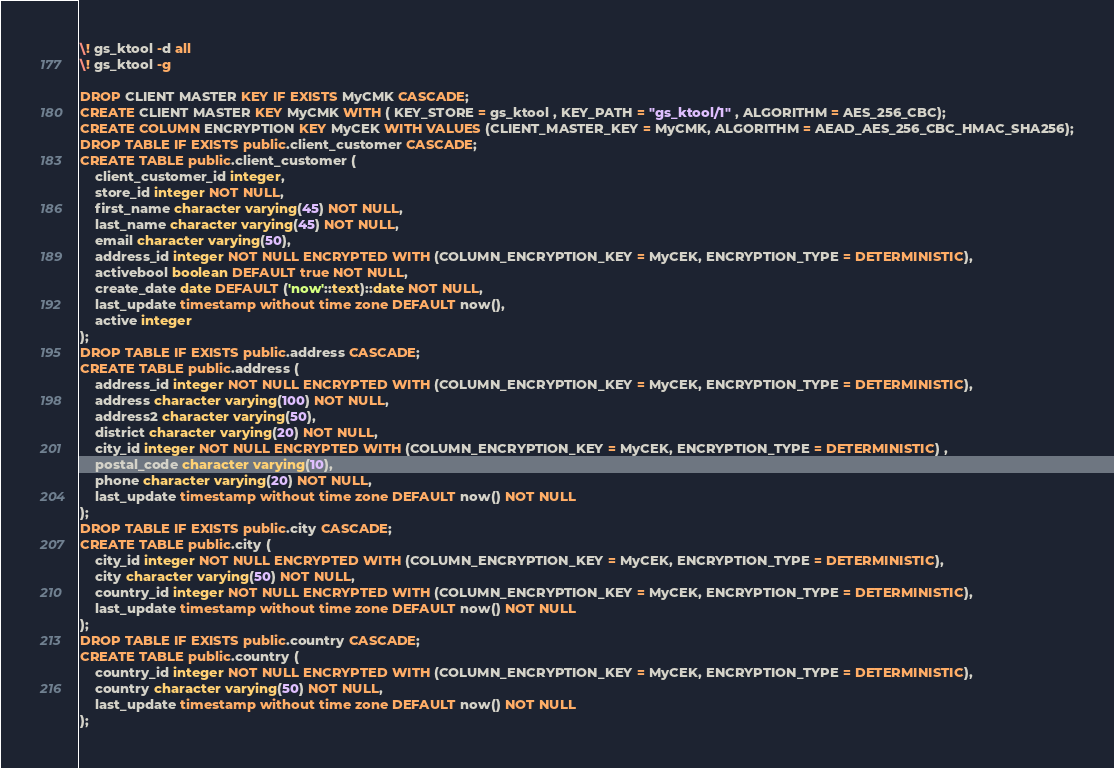<code> <loc_0><loc_0><loc_500><loc_500><_SQL_>\! gs_ktool -d all
\! gs_ktool -g

DROP CLIENT MASTER KEY IF EXISTS MyCMK CASCADE;
CREATE CLIENT MASTER KEY MyCMK WITH ( KEY_STORE = gs_ktool , KEY_PATH = "gs_ktool/1" , ALGORITHM = AES_256_CBC);
CREATE COLUMN ENCRYPTION KEY MyCEK WITH VALUES (CLIENT_MASTER_KEY = MyCMK, ALGORITHM = AEAD_AES_256_CBC_HMAC_SHA256);
DROP TABLE IF EXISTS public.client_customer CASCADE;
CREATE TABLE public.client_customer (
    client_customer_id integer, 
    store_id integer NOT NULL,
    first_name character varying(45) NOT NULL,
    last_name character varying(45) NOT NULL,
    email character varying(50),
    address_id integer NOT NULL ENCRYPTED WITH (COLUMN_ENCRYPTION_KEY = MyCEK, ENCRYPTION_TYPE = DETERMINISTIC),
    activebool boolean DEFAULT true NOT NULL,
    create_date date DEFAULT ('now'::text)::date NOT NULL,
    last_update timestamp without time zone DEFAULT now(),
    active integer
);
DROP TABLE IF EXISTS public.address CASCADE;
CREATE TABLE public.address (
    address_id integer NOT NULL ENCRYPTED WITH (COLUMN_ENCRYPTION_KEY = MyCEK, ENCRYPTION_TYPE = DETERMINISTIC),
    address character varying(100) NOT NULL,
    address2 character varying(50),
    district character varying(20) NOT NULL,
    city_id integer NOT NULL ENCRYPTED WITH (COLUMN_ENCRYPTION_KEY = MyCEK, ENCRYPTION_TYPE = DETERMINISTIC) ,
    postal_code character varying(10),
    phone character varying(20) NOT NULL,
    last_update timestamp without time zone DEFAULT now() NOT NULL
);
DROP TABLE IF EXISTS public.city CASCADE;
CREATE TABLE public.city (
    city_id integer NOT NULL ENCRYPTED WITH (COLUMN_ENCRYPTION_KEY = MyCEK, ENCRYPTION_TYPE = DETERMINISTIC),
    city character varying(50) NOT NULL,
    country_id integer NOT NULL ENCRYPTED WITH (COLUMN_ENCRYPTION_KEY = MyCEK, ENCRYPTION_TYPE = DETERMINISTIC),
    last_update timestamp without time zone DEFAULT now() NOT NULL
);
DROP TABLE IF EXISTS public.country CASCADE;
CREATE TABLE public.country (
    country_id integer NOT NULL ENCRYPTED WITH (COLUMN_ENCRYPTION_KEY = MyCEK, ENCRYPTION_TYPE = DETERMINISTIC),
    country character varying(50) NOT NULL,
    last_update timestamp without time zone DEFAULT now() NOT NULL
);</code> 